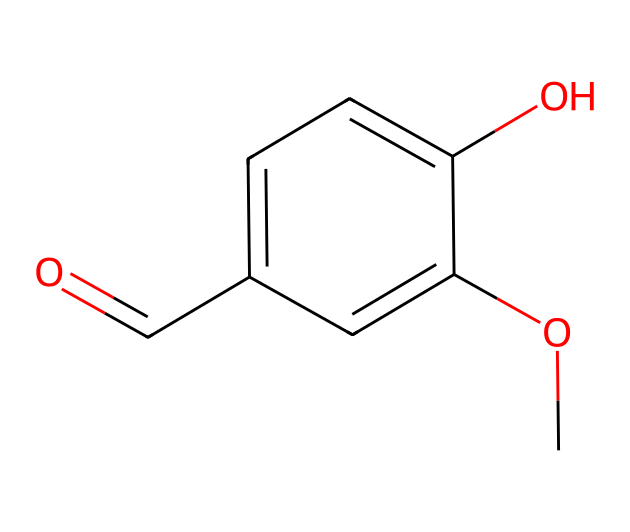What is the molecular formula of vanillin? To determine the molecular formula, count the number of each type of atom in the structure: there are 8 carbons (C), 8 hydrogens (H), and 3 oxygens (O). Thus, the molecular formula is C8H8O3.
Answer: C8H8O3 How many hydroxyl (–OH) groups are in vanillin's structure? In the structure of vanillin, the –OH group is explicitly represented in the chemical. By examining the structure, there is one –OH group attached to the aromatic ring.
Answer: 1 What type of functional group is present in vanillin? Looking at the structure, vanillin shows the presence of both an aldehyde group (–CHO) from the carbonyl (C=O) and a methoxy group (–OCH3). Hence, we can classify the primary functional group as aromatic aldehyde.
Answer: aromatic aldehyde What is the degree of unsaturation in vanillin? To calculate the degree of unsaturation, use the formula: (2C + 2 + N - H - X) / 2. Substituting values for C, H, and considering that there are 0 nitrogens (N) or halogens (X) gives us: (2(8) + 2 - 8) / 2 = 6. The degree of unsaturation indicates the presence of rings and/or double bonds.
Answer: 5 How many aromatic rings are present in the structure of vanillin? The structure shows an aromatic ring, which is identifiable by the alternating double bonds and the specific notation of a phenolic structure. There is only one aromatic ring present in vanillin.
Answer: 1 Is vanillin chiral? To determine chirality, look for a carbon atom bound to four different substituents. In the provided structure, there is no such carbon present. Thus, vanillin is not chiral.
Answer: no 